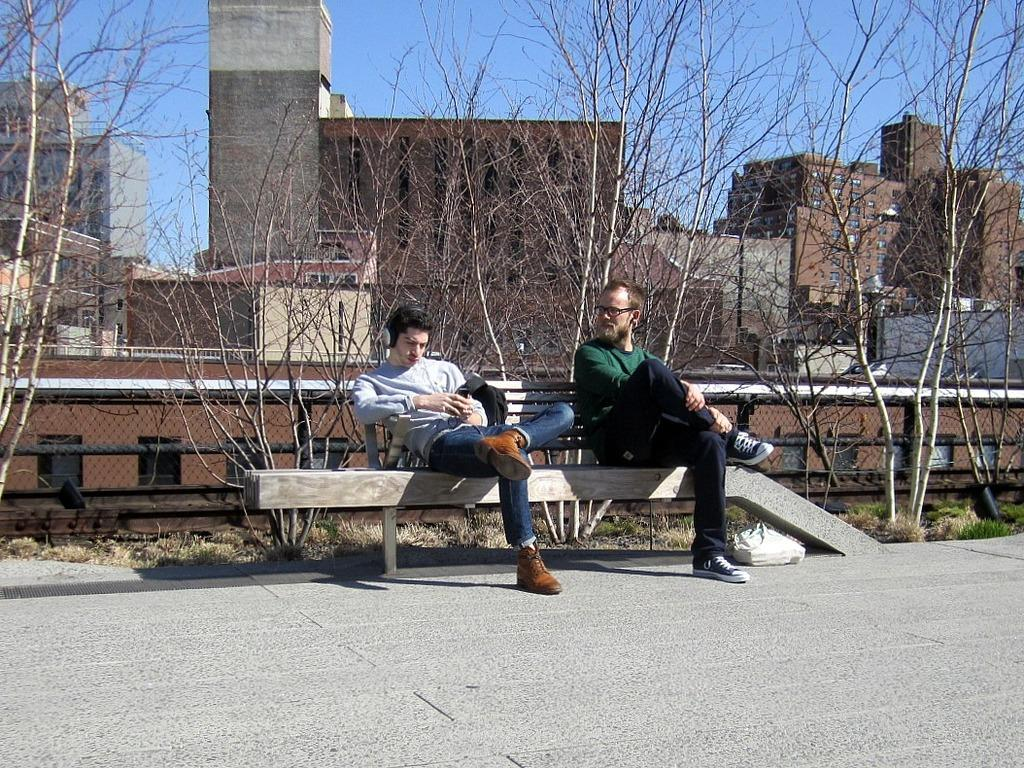How many people are sitting on the bench in the image? There are two persons sitting on a bench in the image. What can be seen in the background of the image? There are trees, buildings, and the sky visible in the background. What type of surface is the bench placed on? There is grass in the image, so the bench is likely placed on grass. What else is present in the image besides the bench and the people sitting on it? There is a road in the image. How many trucks are parked on the grass in the image? There are no trucks present in the image; it features two people sitting on a bench, grass, a road, and a background with trees, buildings, and the sky. What is the wealth status of the people sitting on the bench in the image? There is no information about the wealth status of the people sitting on the bench in the image. 